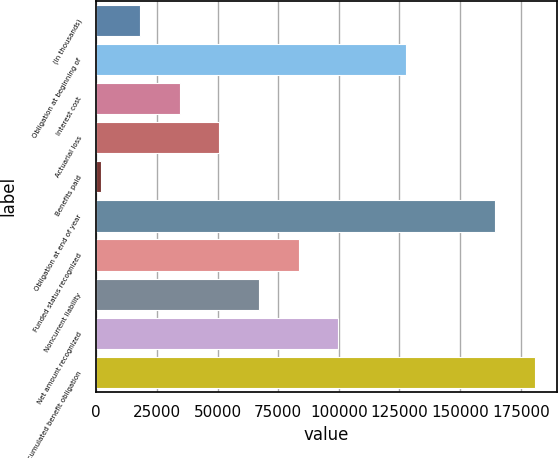Convert chart. <chart><loc_0><loc_0><loc_500><loc_500><bar_chart><fcel>(In thousands)<fcel>Obligation at beginning of<fcel>Interest cost<fcel>Actuarial loss<fcel>Benefits paid<fcel>Obligation at end of year<fcel>Funded status recognized<fcel>Noncurrent liability<fcel>Net amount recognized<fcel>Accumulated benefit obligation<nl><fcel>18169.6<fcel>127617<fcel>34431.2<fcel>50692.8<fcel>1908<fcel>164524<fcel>83479.6<fcel>67218<fcel>99741.2<fcel>180786<nl></chart> 